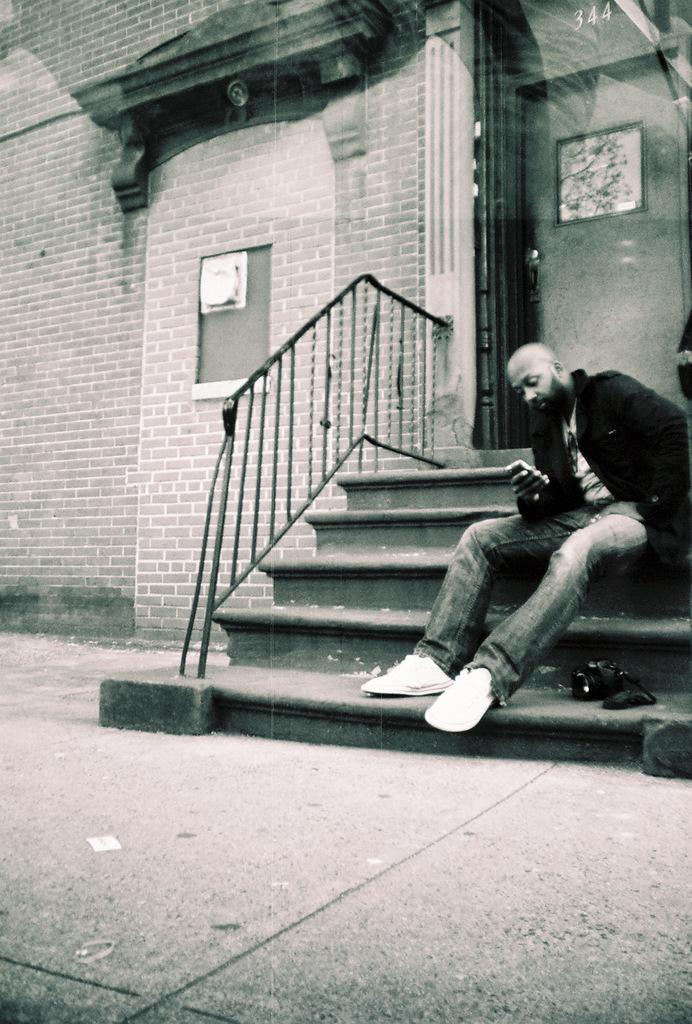Describe this image in one or two sentences. In the center of the image we can see, one person sitting on the staircase and holding some object. In the background there is a building, brick wall, glass, window, photo frame, fence and staircase. 